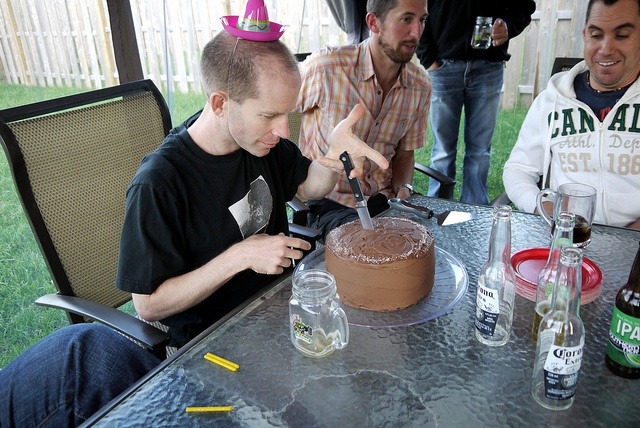Describe the objects in this image and their specific colors. I can see dining table in lightgray, gray, and darkgray tones, people in lightgray, black, tan, gray, and darkgray tones, chair in lightgray, gray, black, and darkgreen tones, people in lightgray, darkgray, black, and brown tones, and people in lightgray, gray, darkgray, and black tones in this image. 